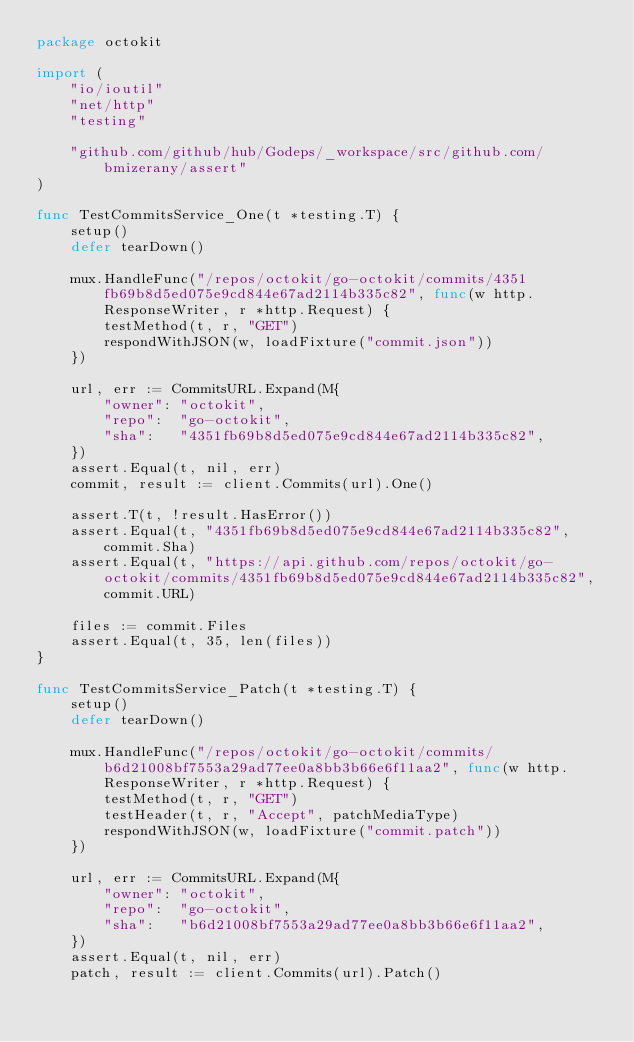<code> <loc_0><loc_0><loc_500><loc_500><_Go_>package octokit

import (
	"io/ioutil"
	"net/http"
	"testing"

	"github.com/github/hub/Godeps/_workspace/src/github.com/bmizerany/assert"
)

func TestCommitsService_One(t *testing.T) {
	setup()
	defer tearDown()

	mux.HandleFunc("/repos/octokit/go-octokit/commits/4351fb69b8d5ed075e9cd844e67ad2114b335c82", func(w http.ResponseWriter, r *http.Request) {
		testMethod(t, r, "GET")
		respondWithJSON(w, loadFixture("commit.json"))
	})

	url, err := CommitsURL.Expand(M{
		"owner": "octokit",
		"repo":  "go-octokit",
		"sha":   "4351fb69b8d5ed075e9cd844e67ad2114b335c82",
	})
	assert.Equal(t, nil, err)
	commit, result := client.Commits(url).One()

	assert.T(t, !result.HasError())
	assert.Equal(t, "4351fb69b8d5ed075e9cd844e67ad2114b335c82", commit.Sha)
	assert.Equal(t, "https://api.github.com/repos/octokit/go-octokit/commits/4351fb69b8d5ed075e9cd844e67ad2114b335c82", commit.URL)

	files := commit.Files
	assert.Equal(t, 35, len(files))
}

func TestCommitsService_Patch(t *testing.T) {
	setup()
	defer tearDown()

	mux.HandleFunc("/repos/octokit/go-octokit/commits/b6d21008bf7553a29ad77ee0a8bb3b66e6f11aa2", func(w http.ResponseWriter, r *http.Request) {
		testMethod(t, r, "GET")
		testHeader(t, r, "Accept", patchMediaType)
		respondWithJSON(w, loadFixture("commit.patch"))
	})

	url, err := CommitsURL.Expand(M{
		"owner": "octokit",
		"repo":  "go-octokit",
		"sha":   "b6d21008bf7553a29ad77ee0a8bb3b66e6f11aa2",
	})
	assert.Equal(t, nil, err)
	patch, result := client.Commits(url).Patch()
</code> 